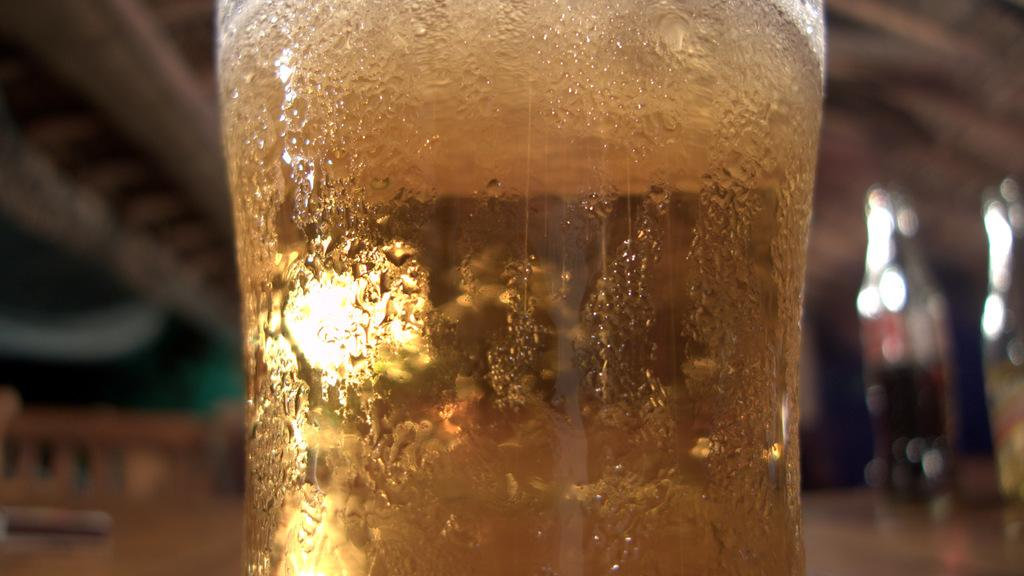What is in the glass that is visible in the image? There is a glass with liquid in the image. Can you describe the background of the image? The background of the image is blurred. How many flowers are present in the image? There are no flowers visible in the image. What type of rail can be seen in the image? There is no rail present in the image. 